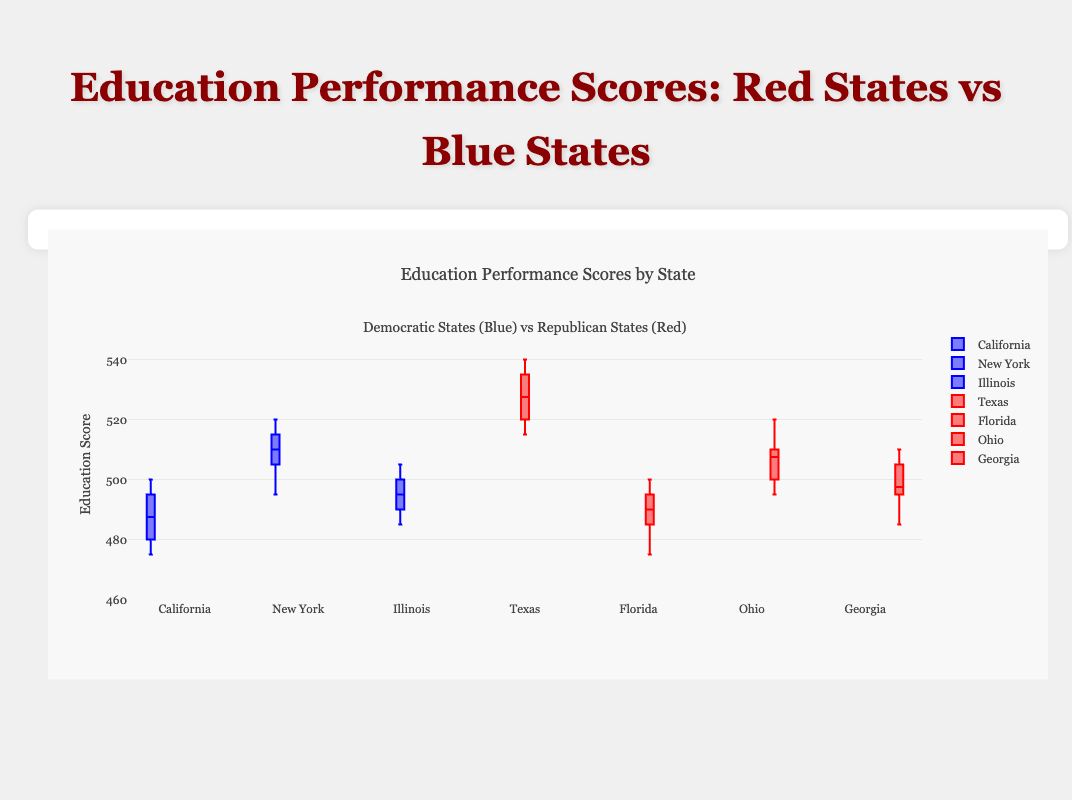What is the title of the plot? The title of the plot is "Education Performance Scores: Red States vs Blue States", which is clearly positioned at the top of the chart, written in a large font.
Answer: Education Performance Scores: Red States vs Blue States How many states with Democratic governance are displayed in the plot? By visually inspecting the legend and the boxed plots, we can see that there are three states with Democratic governance represented: California, New York, and Illinois, indicated by blue box plots.
Answer: 3 Which state has the highest median education score? To determine the state with the highest median education score, look at the middle line of each box plot. Texas, a Republican state, has the highest median line among all the states.
Answer: Texas What is the range of education scores in Florida? The range can be found by identifying the minimum and maximum scores in Florida's box plot. The minimum score is 475, and the maximum score is 500. Therefore, the range is 500 - 475.
Answer: 25 What does the y-axis of the plot represent? The y-axis represents the education scores, with the axis labeled "Education Score" and the values ranging from 460 to 550.
Answer: Education Score How does the variation in education scores between California and Texas compare? By comparing the length of the box plots, California shows a relatively smaller interquartile range (IQR) compared to Texas. Texas's box plot is significantly larger in terms of spread, indicating more substantial variation in education scores.
Answer: Texas has more variation Which state has the smallest interquartile range (IQR)? To find the smallest IQR, compare the width of the boxes of each state. Ohio, a Republican state, shows the smallest IQR, indicating that the middle 50% of its education scores are closer together than in other states.
Answer: Ohio Among Democratic states, which state has the highest median education score? Visually check the middle line in the box plot of Democratic states. New York has the highest median education score among the Democratic states.
Answer: New York What is the difference between the upper quartile of California and Texas? The upper quartile of California is the top of its box, approximately 495. The upper quartile of Texas is at the top of its box, approximately 540. The difference is 540 - 495.
Answer: 45 Which state has the lowest minimum education score? Identify the state's box plot that has the lowest whisker end. California, a Democratic state, has the lowest minimum education score at approximately 475.
Answer: California 